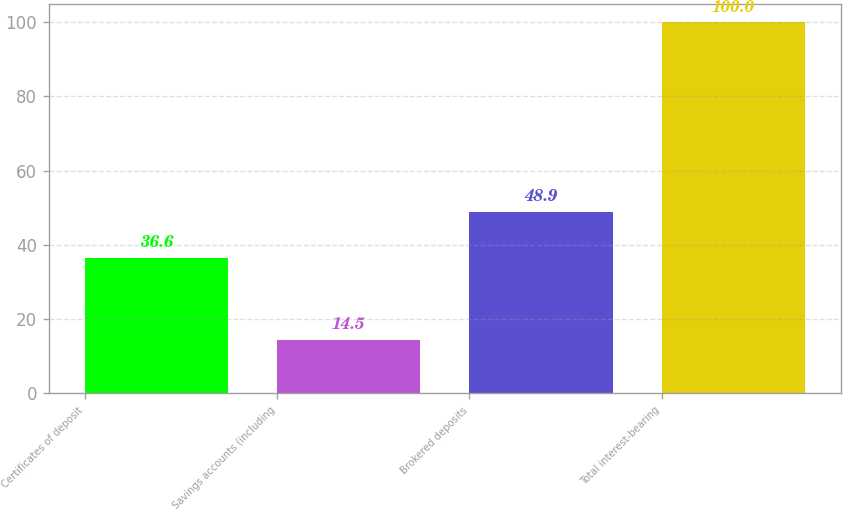Convert chart. <chart><loc_0><loc_0><loc_500><loc_500><bar_chart><fcel>Certificates of deposit<fcel>Savings accounts (including<fcel>Brokered deposits<fcel>Total interest-bearing<nl><fcel>36.6<fcel>14.5<fcel>48.9<fcel>100<nl></chart> 